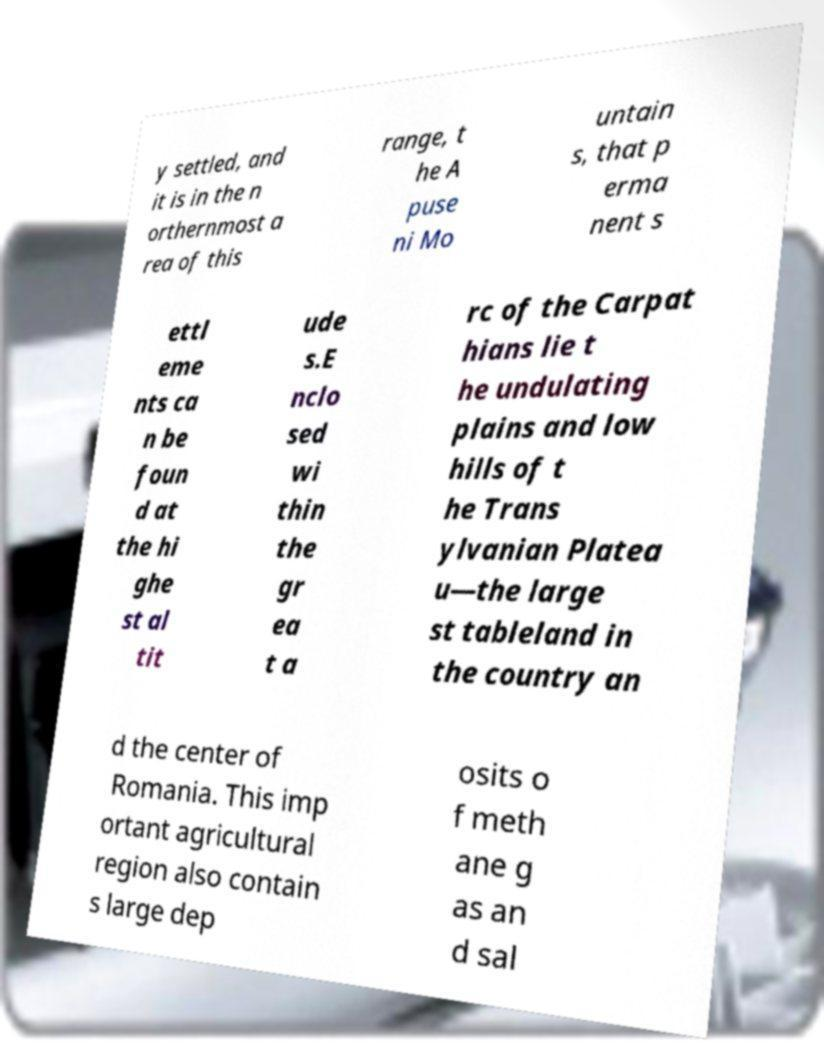Please read and relay the text visible in this image. What does it say? y settled, and it is in the n orthernmost a rea of this range, t he A puse ni Mo untain s, that p erma nent s ettl eme nts ca n be foun d at the hi ghe st al tit ude s.E nclo sed wi thin the gr ea t a rc of the Carpat hians lie t he undulating plains and low hills of t he Trans ylvanian Platea u—the large st tableland in the country an d the center of Romania. This imp ortant agricultural region also contain s large dep osits o f meth ane g as an d sal 